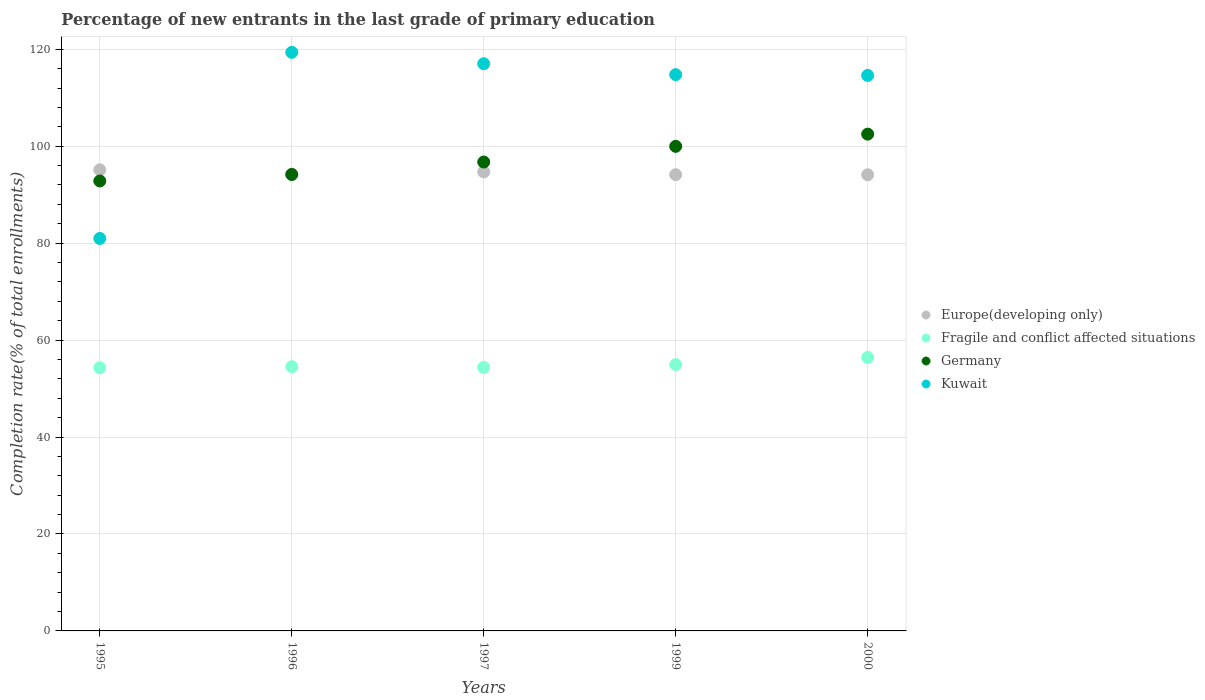How many different coloured dotlines are there?
Provide a short and direct response. 4. Is the number of dotlines equal to the number of legend labels?
Make the answer very short. Yes. What is the percentage of new entrants in Fragile and conflict affected situations in 1997?
Provide a short and direct response. 54.36. Across all years, what is the maximum percentage of new entrants in Fragile and conflict affected situations?
Your answer should be compact. 56.43. Across all years, what is the minimum percentage of new entrants in Kuwait?
Your answer should be very brief. 80.96. In which year was the percentage of new entrants in Kuwait minimum?
Offer a very short reply. 1995. What is the total percentage of new entrants in Fragile and conflict affected situations in the graph?
Keep it short and to the point. 274.54. What is the difference between the percentage of new entrants in Europe(developing only) in 1996 and that in 1997?
Offer a terse response. -0.46. What is the difference between the percentage of new entrants in Fragile and conflict affected situations in 1997 and the percentage of new entrants in Germany in 1999?
Offer a very short reply. -45.61. What is the average percentage of new entrants in Fragile and conflict affected situations per year?
Offer a terse response. 54.91. In the year 2000, what is the difference between the percentage of new entrants in Kuwait and percentage of new entrants in Germany?
Your response must be concise. 12.12. In how many years, is the percentage of new entrants in Europe(developing only) greater than 72 %?
Ensure brevity in your answer.  5. What is the ratio of the percentage of new entrants in Germany in 1995 to that in 1999?
Keep it short and to the point. 0.93. What is the difference between the highest and the second highest percentage of new entrants in Germany?
Your answer should be very brief. 2.52. What is the difference between the highest and the lowest percentage of new entrants in Germany?
Make the answer very short. 9.66. Is it the case that in every year, the sum of the percentage of new entrants in Germany and percentage of new entrants in Fragile and conflict affected situations  is greater than the sum of percentage of new entrants in Europe(developing only) and percentage of new entrants in Kuwait?
Give a very brief answer. No. Is it the case that in every year, the sum of the percentage of new entrants in Germany and percentage of new entrants in Kuwait  is greater than the percentage of new entrants in Fragile and conflict affected situations?
Make the answer very short. Yes. Is the percentage of new entrants in Kuwait strictly greater than the percentage of new entrants in Fragile and conflict affected situations over the years?
Offer a very short reply. Yes. Is the percentage of new entrants in Fragile and conflict affected situations strictly less than the percentage of new entrants in Kuwait over the years?
Your answer should be compact. Yes. What is the difference between two consecutive major ticks on the Y-axis?
Give a very brief answer. 20. Are the values on the major ticks of Y-axis written in scientific E-notation?
Your answer should be compact. No. Does the graph contain any zero values?
Provide a short and direct response. No. How many legend labels are there?
Make the answer very short. 4. What is the title of the graph?
Make the answer very short. Percentage of new entrants in the last grade of primary education. What is the label or title of the Y-axis?
Give a very brief answer. Completion rate(% of total enrollments). What is the Completion rate(% of total enrollments) of Europe(developing only) in 1995?
Give a very brief answer. 95.14. What is the Completion rate(% of total enrollments) in Fragile and conflict affected situations in 1995?
Your response must be concise. 54.29. What is the Completion rate(% of total enrollments) of Germany in 1995?
Your answer should be compact. 92.82. What is the Completion rate(% of total enrollments) of Kuwait in 1995?
Make the answer very short. 80.96. What is the Completion rate(% of total enrollments) in Europe(developing only) in 1996?
Offer a very short reply. 94.23. What is the Completion rate(% of total enrollments) in Fragile and conflict affected situations in 1996?
Give a very brief answer. 54.51. What is the Completion rate(% of total enrollments) of Germany in 1996?
Your answer should be very brief. 94.16. What is the Completion rate(% of total enrollments) of Kuwait in 1996?
Ensure brevity in your answer.  119.36. What is the Completion rate(% of total enrollments) in Europe(developing only) in 1997?
Make the answer very short. 94.69. What is the Completion rate(% of total enrollments) in Fragile and conflict affected situations in 1997?
Keep it short and to the point. 54.36. What is the Completion rate(% of total enrollments) of Germany in 1997?
Provide a short and direct response. 96.73. What is the Completion rate(% of total enrollments) in Kuwait in 1997?
Keep it short and to the point. 117.01. What is the Completion rate(% of total enrollments) in Europe(developing only) in 1999?
Keep it short and to the point. 94.12. What is the Completion rate(% of total enrollments) of Fragile and conflict affected situations in 1999?
Your response must be concise. 54.94. What is the Completion rate(% of total enrollments) in Germany in 1999?
Ensure brevity in your answer.  99.97. What is the Completion rate(% of total enrollments) of Kuwait in 1999?
Ensure brevity in your answer.  114.76. What is the Completion rate(% of total enrollments) of Europe(developing only) in 2000?
Your answer should be compact. 94.1. What is the Completion rate(% of total enrollments) in Fragile and conflict affected situations in 2000?
Make the answer very short. 56.43. What is the Completion rate(% of total enrollments) of Germany in 2000?
Keep it short and to the point. 102.49. What is the Completion rate(% of total enrollments) of Kuwait in 2000?
Provide a short and direct response. 114.61. Across all years, what is the maximum Completion rate(% of total enrollments) of Europe(developing only)?
Give a very brief answer. 95.14. Across all years, what is the maximum Completion rate(% of total enrollments) in Fragile and conflict affected situations?
Give a very brief answer. 56.43. Across all years, what is the maximum Completion rate(% of total enrollments) in Germany?
Provide a succinct answer. 102.49. Across all years, what is the maximum Completion rate(% of total enrollments) in Kuwait?
Your answer should be very brief. 119.36. Across all years, what is the minimum Completion rate(% of total enrollments) of Europe(developing only)?
Provide a succinct answer. 94.1. Across all years, what is the minimum Completion rate(% of total enrollments) of Fragile and conflict affected situations?
Provide a short and direct response. 54.29. Across all years, what is the minimum Completion rate(% of total enrollments) in Germany?
Offer a very short reply. 92.82. Across all years, what is the minimum Completion rate(% of total enrollments) in Kuwait?
Provide a succinct answer. 80.96. What is the total Completion rate(% of total enrollments) of Europe(developing only) in the graph?
Give a very brief answer. 472.27. What is the total Completion rate(% of total enrollments) of Fragile and conflict affected situations in the graph?
Your answer should be compact. 274.54. What is the total Completion rate(% of total enrollments) in Germany in the graph?
Provide a succinct answer. 486.17. What is the total Completion rate(% of total enrollments) of Kuwait in the graph?
Make the answer very short. 546.7. What is the difference between the Completion rate(% of total enrollments) of Europe(developing only) in 1995 and that in 1996?
Your answer should be compact. 0.91. What is the difference between the Completion rate(% of total enrollments) of Fragile and conflict affected situations in 1995 and that in 1996?
Offer a very short reply. -0.22. What is the difference between the Completion rate(% of total enrollments) in Germany in 1995 and that in 1996?
Your answer should be very brief. -1.34. What is the difference between the Completion rate(% of total enrollments) in Kuwait in 1995 and that in 1996?
Make the answer very short. -38.4. What is the difference between the Completion rate(% of total enrollments) in Europe(developing only) in 1995 and that in 1997?
Your answer should be very brief. 0.45. What is the difference between the Completion rate(% of total enrollments) in Fragile and conflict affected situations in 1995 and that in 1997?
Ensure brevity in your answer.  -0.07. What is the difference between the Completion rate(% of total enrollments) of Germany in 1995 and that in 1997?
Your answer should be compact. -3.91. What is the difference between the Completion rate(% of total enrollments) in Kuwait in 1995 and that in 1997?
Provide a succinct answer. -36.05. What is the difference between the Completion rate(% of total enrollments) in Europe(developing only) in 1995 and that in 1999?
Make the answer very short. 1.02. What is the difference between the Completion rate(% of total enrollments) of Fragile and conflict affected situations in 1995 and that in 1999?
Provide a succinct answer. -0.64. What is the difference between the Completion rate(% of total enrollments) in Germany in 1995 and that in 1999?
Ensure brevity in your answer.  -7.14. What is the difference between the Completion rate(% of total enrollments) in Kuwait in 1995 and that in 1999?
Provide a succinct answer. -33.8. What is the difference between the Completion rate(% of total enrollments) of Europe(developing only) in 1995 and that in 2000?
Provide a short and direct response. 1.04. What is the difference between the Completion rate(% of total enrollments) of Fragile and conflict affected situations in 1995 and that in 2000?
Provide a short and direct response. -2.14. What is the difference between the Completion rate(% of total enrollments) in Germany in 1995 and that in 2000?
Give a very brief answer. -9.66. What is the difference between the Completion rate(% of total enrollments) in Kuwait in 1995 and that in 2000?
Your answer should be compact. -33.64. What is the difference between the Completion rate(% of total enrollments) of Europe(developing only) in 1996 and that in 1997?
Ensure brevity in your answer.  -0.46. What is the difference between the Completion rate(% of total enrollments) in Fragile and conflict affected situations in 1996 and that in 1997?
Make the answer very short. 0.15. What is the difference between the Completion rate(% of total enrollments) in Germany in 1996 and that in 1997?
Your response must be concise. -2.57. What is the difference between the Completion rate(% of total enrollments) in Kuwait in 1996 and that in 1997?
Your answer should be very brief. 2.35. What is the difference between the Completion rate(% of total enrollments) in Europe(developing only) in 1996 and that in 1999?
Offer a very short reply. 0.11. What is the difference between the Completion rate(% of total enrollments) of Fragile and conflict affected situations in 1996 and that in 1999?
Your answer should be very brief. -0.42. What is the difference between the Completion rate(% of total enrollments) in Germany in 1996 and that in 1999?
Your answer should be very brief. -5.81. What is the difference between the Completion rate(% of total enrollments) of Kuwait in 1996 and that in 1999?
Keep it short and to the point. 4.6. What is the difference between the Completion rate(% of total enrollments) in Europe(developing only) in 1996 and that in 2000?
Make the answer very short. 0.13. What is the difference between the Completion rate(% of total enrollments) of Fragile and conflict affected situations in 1996 and that in 2000?
Your answer should be compact. -1.92. What is the difference between the Completion rate(% of total enrollments) of Germany in 1996 and that in 2000?
Provide a short and direct response. -8.33. What is the difference between the Completion rate(% of total enrollments) of Kuwait in 1996 and that in 2000?
Offer a terse response. 4.75. What is the difference between the Completion rate(% of total enrollments) of Europe(developing only) in 1997 and that in 1999?
Provide a short and direct response. 0.57. What is the difference between the Completion rate(% of total enrollments) in Fragile and conflict affected situations in 1997 and that in 1999?
Offer a very short reply. -0.58. What is the difference between the Completion rate(% of total enrollments) in Germany in 1997 and that in 1999?
Ensure brevity in your answer.  -3.23. What is the difference between the Completion rate(% of total enrollments) of Kuwait in 1997 and that in 1999?
Make the answer very short. 2.25. What is the difference between the Completion rate(% of total enrollments) in Europe(developing only) in 1997 and that in 2000?
Your answer should be compact. 0.59. What is the difference between the Completion rate(% of total enrollments) in Fragile and conflict affected situations in 1997 and that in 2000?
Provide a short and direct response. -2.07. What is the difference between the Completion rate(% of total enrollments) in Germany in 1997 and that in 2000?
Your answer should be compact. -5.76. What is the difference between the Completion rate(% of total enrollments) in Kuwait in 1997 and that in 2000?
Ensure brevity in your answer.  2.4. What is the difference between the Completion rate(% of total enrollments) of Europe(developing only) in 1999 and that in 2000?
Keep it short and to the point. 0.02. What is the difference between the Completion rate(% of total enrollments) in Fragile and conflict affected situations in 1999 and that in 2000?
Provide a succinct answer. -1.5. What is the difference between the Completion rate(% of total enrollments) in Germany in 1999 and that in 2000?
Your answer should be compact. -2.52. What is the difference between the Completion rate(% of total enrollments) in Kuwait in 1999 and that in 2000?
Give a very brief answer. 0.15. What is the difference between the Completion rate(% of total enrollments) in Europe(developing only) in 1995 and the Completion rate(% of total enrollments) in Fragile and conflict affected situations in 1996?
Offer a terse response. 40.62. What is the difference between the Completion rate(% of total enrollments) of Europe(developing only) in 1995 and the Completion rate(% of total enrollments) of Germany in 1996?
Keep it short and to the point. 0.98. What is the difference between the Completion rate(% of total enrollments) of Europe(developing only) in 1995 and the Completion rate(% of total enrollments) of Kuwait in 1996?
Keep it short and to the point. -24.22. What is the difference between the Completion rate(% of total enrollments) in Fragile and conflict affected situations in 1995 and the Completion rate(% of total enrollments) in Germany in 1996?
Ensure brevity in your answer.  -39.87. What is the difference between the Completion rate(% of total enrollments) of Fragile and conflict affected situations in 1995 and the Completion rate(% of total enrollments) of Kuwait in 1996?
Make the answer very short. -65.07. What is the difference between the Completion rate(% of total enrollments) of Germany in 1995 and the Completion rate(% of total enrollments) of Kuwait in 1996?
Provide a short and direct response. -26.54. What is the difference between the Completion rate(% of total enrollments) of Europe(developing only) in 1995 and the Completion rate(% of total enrollments) of Fragile and conflict affected situations in 1997?
Give a very brief answer. 40.78. What is the difference between the Completion rate(% of total enrollments) in Europe(developing only) in 1995 and the Completion rate(% of total enrollments) in Germany in 1997?
Give a very brief answer. -1.6. What is the difference between the Completion rate(% of total enrollments) in Europe(developing only) in 1995 and the Completion rate(% of total enrollments) in Kuwait in 1997?
Your answer should be very brief. -21.87. What is the difference between the Completion rate(% of total enrollments) in Fragile and conflict affected situations in 1995 and the Completion rate(% of total enrollments) in Germany in 1997?
Ensure brevity in your answer.  -42.44. What is the difference between the Completion rate(% of total enrollments) of Fragile and conflict affected situations in 1995 and the Completion rate(% of total enrollments) of Kuwait in 1997?
Make the answer very short. -62.72. What is the difference between the Completion rate(% of total enrollments) in Germany in 1995 and the Completion rate(% of total enrollments) in Kuwait in 1997?
Offer a very short reply. -24.19. What is the difference between the Completion rate(% of total enrollments) of Europe(developing only) in 1995 and the Completion rate(% of total enrollments) of Fragile and conflict affected situations in 1999?
Offer a very short reply. 40.2. What is the difference between the Completion rate(% of total enrollments) in Europe(developing only) in 1995 and the Completion rate(% of total enrollments) in Germany in 1999?
Your answer should be very brief. -4.83. What is the difference between the Completion rate(% of total enrollments) of Europe(developing only) in 1995 and the Completion rate(% of total enrollments) of Kuwait in 1999?
Your answer should be compact. -19.62. What is the difference between the Completion rate(% of total enrollments) in Fragile and conflict affected situations in 1995 and the Completion rate(% of total enrollments) in Germany in 1999?
Offer a terse response. -45.67. What is the difference between the Completion rate(% of total enrollments) of Fragile and conflict affected situations in 1995 and the Completion rate(% of total enrollments) of Kuwait in 1999?
Ensure brevity in your answer.  -60.47. What is the difference between the Completion rate(% of total enrollments) in Germany in 1995 and the Completion rate(% of total enrollments) in Kuwait in 1999?
Your answer should be very brief. -21.94. What is the difference between the Completion rate(% of total enrollments) in Europe(developing only) in 1995 and the Completion rate(% of total enrollments) in Fragile and conflict affected situations in 2000?
Your answer should be very brief. 38.7. What is the difference between the Completion rate(% of total enrollments) of Europe(developing only) in 1995 and the Completion rate(% of total enrollments) of Germany in 2000?
Keep it short and to the point. -7.35. What is the difference between the Completion rate(% of total enrollments) in Europe(developing only) in 1995 and the Completion rate(% of total enrollments) in Kuwait in 2000?
Make the answer very short. -19.47. What is the difference between the Completion rate(% of total enrollments) in Fragile and conflict affected situations in 1995 and the Completion rate(% of total enrollments) in Germany in 2000?
Your response must be concise. -48.2. What is the difference between the Completion rate(% of total enrollments) in Fragile and conflict affected situations in 1995 and the Completion rate(% of total enrollments) in Kuwait in 2000?
Offer a very short reply. -60.31. What is the difference between the Completion rate(% of total enrollments) in Germany in 1995 and the Completion rate(% of total enrollments) in Kuwait in 2000?
Your response must be concise. -21.78. What is the difference between the Completion rate(% of total enrollments) of Europe(developing only) in 1996 and the Completion rate(% of total enrollments) of Fragile and conflict affected situations in 1997?
Provide a succinct answer. 39.87. What is the difference between the Completion rate(% of total enrollments) of Europe(developing only) in 1996 and the Completion rate(% of total enrollments) of Germany in 1997?
Give a very brief answer. -2.5. What is the difference between the Completion rate(% of total enrollments) in Europe(developing only) in 1996 and the Completion rate(% of total enrollments) in Kuwait in 1997?
Provide a short and direct response. -22.78. What is the difference between the Completion rate(% of total enrollments) of Fragile and conflict affected situations in 1996 and the Completion rate(% of total enrollments) of Germany in 1997?
Your response must be concise. -42.22. What is the difference between the Completion rate(% of total enrollments) in Fragile and conflict affected situations in 1996 and the Completion rate(% of total enrollments) in Kuwait in 1997?
Make the answer very short. -62.5. What is the difference between the Completion rate(% of total enrollments) in Germany in 1996 and the Completion rate(% of total enrollments) in Kuwait in 1997?
Give a very brief answer. -22.85. What is the difference between the Completion rate(% of total enrollments) in Europe(developing only) in 1996 and the Completion rate(% of total enrollments) in Fragile and conflict affected situations in 1999?
Offer a very short reply. 39.29. What is the difference between the Completion rate(% of total enrollments) in Europe(developing only) in 1996 and the Completion rate(% of total enrollments) in Germany in 1999?
Your answer should be compact. -5.74. What is the difference between the Completion rate(% of total enrollments) of Europe(developing only) in 1996 and the Completion rate(% of total enrollments) of Kuwait in 1999?
Your response must be concise. -20.53. What is the difference between the Completion rate(% of total enrollments) of Fragile and conflict affected situations in 1996 and the Completion rate(% of total enrollments) of Germany in 1999?
Your response must be concise. -45.45. What is the difference between the Completion rate(% of total enrollments) in Fragile and conflict affected situations in 1996 and the Completion rate(% of total enrollments) in Kuwait in 1999?
Make the answer very short. -60.25. What is the difference between the Completion rate(% of total enrollments) in Germany in 1996 and the Completion rate(% of total enrollments) in Kuwait in 1999?
Your answer should be compact. -20.6. What is the difference between the Completion rate(% of total enrollments) of Europe(developing only) in 1996 and the Completion rate(% of total enrollments) of Fragile and conflict affected situations in 2000?
Ensure brevity in your answer.  37.79. What is the difference between the Completion rate(% of total enrollments) of Europe(developing only) in 1996 and the Completion rate(% of total enrollments) of Germany in 2000?
Offer a very short reply. -8.26. What is the difference between the Completion rate(% of total enrollments) of Europe(developing only) in 1996 and the Completion rate(% of total enrollments) of Kuwait in 2000?
Your answer should be very brief. -20.38. What is the difference between the Completion rate(% of total enrollments) in Fragile and conflict affected situations in 1996 and the Completion rate(% of total enrollments) in Germany in 2000?
Offer a terse response. -47.97. What is the difference between the Completion rate(% of total enrollments) in Fragile and conflict affected situations in 1996 and the Completion rate(% of total enrollments) in Kuwait in 2000?
Your answer should be very brief. -60.09. What is the difference between the Completion rate(% of total enrollments) in Germany in 1996 and the Completion rate(% of total enrollments) in Kuwait in 2000?
Make the answer very short. -20.45. What is the difference between the Completion rate(% of total enrollments) of Europe(developing only) in 1997 and the Completion rate(% of total enrollments) of Fragile and conflict affected situations in 1999?
Your answer should be very brief. 39.75. What is the difference between the Completion rate(% of total enrollments) in Europe(developing only) in 1997 and the Completion rate(% of total enrollments) in Germany in 1999?
Your answer should be very brief. -5.28. What is the difference between the Completion rate(% of total enrollments) in Europe(developing only) in 1997 and the Completion rate(% of total enrollments) in Kuwait in 1999?
Make the answer very short. -20.07. What is the difference between the Completion rate(% of total enrollments) in Fragile and conflict affected situations in 1997 and the Completion rate(% of total enrollments) in Germany in 1999?
Ensure brevity in your answer.  -45.61. What is the difference between the Completion rate(% of total enrollments) in Fragile and conflict affected situations in 1997 and the Completion rate(% of total enrollments) in Kuwait in 1999?
Provide a succinct answer. -60.4. What is the difference between the Completion rate(% of total enrollments) in Germany in 1997 and the Completion rate(% of total enrollments) in Kuwait in 1999?
Keep it short and to the point. -18.03. What is the difference between the Completion rate(% of total enrollments) in Europe(developing only) in 1997 and the Completion rate(% of total enrollments) in Fragile and conflict affected situations in 2000?
Provide a succinct answer. 38.25. What is the difference between the Completion rate(% of total enrollments) in Europe(developing only) in 1997 and the Completion rate(% of total enrollments) in Germany in 2000?
Provide a short and direct response. -7.8. What is the difference between the Completion rate(% of total enrollments) in Europe(developing only) in 1997 and the Completion rate(% of total enrollments) in Kuwait in 2000?
Give a very brief answer. -19.92. What is the difference between the Completion rate(% of total enrollments) of Fragile and conflict affected situations in 1997 and the Completion rate(% of total enrollments) of Germany in 2000?
Ensure brevity in your answer.  -48.13. What is the difference between the Completion rate(% of total enrollments) of Fragile and conflict affected situations in 1997 and the Completion rate(% of total enrollments) of Kuwait in 2000?
Offer a very short reply. -60.25. What is the difference between the Completion rate(% of total enrollments) in Germany in 1997 and the Completion rate(% of total enrollments) in Kuwait in 2000?
Provide a succinct answer. -17.87. What is the difference between the Completion rate(% of total enrollments) of Europe(developing only) in 1999 and the Completion rate(% of total enrollments) of Fragile and conflict affected situations in 2000?
Make the answer very short. 37.68. What is the difference between the Completion rate(% of total enrollments) in Europe(developing only) in 1999 and the Completion rate(% of total enrollments) in Germany in 2000?
Provide a short and direct response. -8.37. What is the difference between the Completion rate(% of total enrollments) in Europe(developing only) in 1999 and the Completion rate(% of total enrollments) in Kuwait in 2000?
Keep it short and to the point. -20.49. What is the difference between the Completion rate(% of total enrollments) of Fragile and conflict affected situations in 1999 and the Completion rate(% of total enrollments) of Germany in 2000?
Provide a succinct answer. -47.55. What is the difference between the Completion rate(% of total enrollments) in Fragile and conflict affected situations in 1999 and the Completion rate(% of total enrollments) in Kuwait in 2000?
Make the answer very short. -59.67. What is the difference between the Completion rate(% of total enrollments) in Germany in 1999 and the Completion rate(% of total enrollments) in Kuwait in 2000?
Your response must be concise. -14.64. What is the average Completion rate(% of total enrollments) of Europe(developing only) per year?
Provide a succinct answer. 94.45. What is the average Completion rate(% of total enrollments) of Fragile and conflict affected situations per year?
Your response must be concise. 54.91. What is the average Completion rate(% of total enrollments) of Germany per year?
Your response must be concise. 97.23. What is the average Completion rate(% of total enrollments) of Kuwait per year?
Provide a succinct answer. 109.34. In the year 1995, what is the difference between the Completion rate(% of total enrollments) of Europe(developing only) and Completion rate(% of total enrollments) of Fragile and conflict affected situations?
Your response must be concise. 40.84. In the year 1995, what is the difference between the Completion rate(% of total enrollments) in Europe(developing only) and Completion rate(% of total enrollments) in Germany?
Give a very brief answer. 2.31. In the year 1995, what is the difference between the Completion rate(% of total enrollments) of Europe(developing only) and Completion rate(% of total enrollments) of Kuwait?
Provide a short and direct response. 14.17. In the year 1995, what is the difference between the Completion rate(% of total enrollments) of Fragile and conflict affected situations and Completion rate(% of total enrollments) of Germany?
Your answer should be compact. -38.53. In the year 1995, what is the difference between the Completion rate(% of total enrollments) in Fragile and conflict affected situations and Completion rate(% of total enrollments) in Kuwait?
Keep it short and to the point. -26.67. In the year 1995, what is the difference between the Completion rate(% of total enrollments) in Germany and Completion rate(% of total enrollments) in Kuwait?
Give a very brief answer. 11.86. In the year 1996, what is the difference between the Completion rate(% of total enrollments) in Europe(developing only) and Completion rate(% of total enrollments) in Fragile and conflict affected situations?
Provide a succinct answer. 39.71. In the year 1996, what is the difference between the Completion rate(% of total enrollments) of Europe(developing only) and Completion rate(% of total enrollments) of Germany?
Provide a succinct answer. 0.07. In the year 1996, what is the difference between the Completion rate(% of total enrollments) in Europe(developing only) and Completion rate(% of total enrollments) in Kuwait?
Provide a short and direct response. -25.13. In the year 1996, what is the difference between the Completion rate(% of total enrollments) in Fragile and conflict affected situations and Completion rate(% of total enrollments) in Germany?
Your answer should be very brief. -39.65. In the year 1996, what is the difference between the Completion rate(% of total enrollments) of Fragile and conflict affected situations and Completion rate(% of total enrollments) of Kuwait?
Your response must be concise. -64.85. In the year 1996, what is the difference between the Completion rate(% of total enrollments) in Germany and Completion rate(% of total enrollments) in Kuwait?
Provide a short and direct response. -25.2. In the year 1997, what is the difference between the Completion rate(% of total enrollments) of Europe(developing only) and Completion rate(% of total enrollments) of Fragile and conflict affected situations?
Keep it short and to the point. 40.33. In the year 1997, what is the difference between the Completion rate(% of total enrollments) of Europe(developing only) and Completion rate(% of total enrollments) of Germany?
Give a very brief answer. -2.04. In the year 1997, what is the difference between the Completion rate(% of total enrollments) of Europe(developing only) and Completion rate(% of total enrollments) of Kuwait?
Keep it short and to the point. -22.32. In the year 1997, what is the difference between the Completion rate(% of total enrollments) in Fragile and conflict affected situations and Completion rate(% of total enrollments) in Germany?
Make the answer very short. -42.37. In the year 1997, what is the difference between the Completion rate(% of total enrollments) in Fragile and conflict affected situations and Completion rate(% of total enrollments) in Kuwait?
Keep it short and to the point. -62.65. In the year 1997, what is the difference between the Completion rate(% of total enrollments) of Germany and Completion rate(% of total enrollments) of Kuwait?
Keep it short and to the point. -20.28. In the year 1999, what is the difference between the Completion rate(% of total enrollments) of Europe(developing only) and Completion rate(% of total enrollments) of Fragile and conflict affected situations?
Provide a short and direct response. 39.18. In the year 1999, what is the difference between the Completion rate(% of total enrollments) in Europe(developing only) and Completion rate(% of total enrollments) in Germany?
Your answer should be compact. -5.85. In the year 1999, what is the difference between the Completion rate(% of total enrollments) of Europe(developing only) and Completion rate(% of total enrollments) of Kuwait?
Offer a terse response. -20.64. In the year 1999, what is the difference between the Completion rate(% of total enrollments) of Fragile and conflict affected situations and Completion rate(% of total enrollments) of Germany?
Offer a very short reply. -45.03. In the year 1999, what is the difference between the Completion rate(% of total enrollments) of Fragile and conflict affected situations and Completion rate(% of total enrollments) of Kuwait?
Your response must be concise. -59.82. In the year 1999, what is the difference between the Completion rate(% of total enrollments) of Germany and Completion rate(% of total enrollments) of Kuwait?
Provide a succinct answer. -14.79. In the year 2000, what is the difference between the Completion rate(% of total enrollments) in Europe(developing only) and Completion rate(% of total enrollments) in Fragile and conflict affected situations?
Give a very brief answer. 37.67. In the year 2000, what is the difference between the Completion rate(% of total enrollments) in Europe(developing only) and Completion rate(% of total enrollments) in Germany?
Make the answer very short. -8.39. In the year 2000, what is the difference between the Completion rate(% of total enrollments) in Europe(developing only) and Completion rate(% of total enrollments) in Kuwait?
Ensure brevity in your answer.  -20.51. In the year 2000, what is the difference between the Completion rate(% of total enrollments) of Fragile and conflict affected situations and Completion rate(% of total enrollments) of Germany?
Make the answer very short. -46.05. In the year 2000, what is the difference between the Completion rate(% of total enrollments) in Fragile and conflict affected situations and Completion rate(% of total enrollments) in Kuwait?
Provide a succinct answer. -58.17. In the year 2000, what is the difference between the Completion rate(% of total enrollments) of Germany and Completion rate(% of total enrollments) of Kuwait?
Give a very brief answer. -12.12. What is the ratio of the Completion rate(% of total enrollments) in Europe(developing only) in 1995 to that in 1996?
Your response must be concise. 1.01. What is the ratio of the Completion rate(% of total enrollments) of Fragile and conflict affected situations in 1995 to that in 1996?
Ensure brevity in your answer.  1. What is the ratio of the Completion rate(% of total enrollments) in Germany in 1995 to that in 1996?
Your answer should be very brief. 0.99. What is the ratio of the Completion rate(% of total enrollments) in Kuwait in 1995 to that in 1996?
Your answer should be compact. 0.68. What is the ratio of the Completion rate(% of total enrollments) in Fragile and conflict affected situations in 1995 to that in 1997?
Your answer should be compact. 1. What is the ratio of the Completion rate(% of total enrollments) of Germany in 1995 to that in 1997?
Keep it short and to the point. 0.96. What is the ratio of the Completion rate(% of total enrollments) in Kuwait in 1995 to that in 1997?
Give a very brief answer. 0.69. What is the ratio of the Completion rate(% of total enrollments) of Europe(developing only) in 1995 to that in 1999?
Offer a very short reply. 1.01. What is the ratio of the Completion rate(% of total enrollments) of Fragile and conflict affected situations in 1995 to that in 1999?
Provide a succinct answer. 0.99. What is the ratio of the Completion rate(% of total enrollments) in Germany in 1995 to that in 1999?
Give a very brief answer. 0.93. What is the ratio of the Completion rate(% of total enrollments) of Kuwait in 1995 to that in 1999?
Provide a succinct answer. 0.71. What is the ratio of the Completion rate(% of total enrollments) of Europe(developing only) in 1995 to that in 2000?
Give a very brief answer. 1.01. What is the ratio of the Completion rate(% of total enrollments) of Germany in 1995 to that in 2000?
Offer a terse response. 0.91. What is the ratio of the Completion rate(% of total enrollments) of Kuwait in 1995 to that in 2000?
Your response must be concise. 0.71. What is the ratio of the Completion rate(% of total enrollments) in Germany in 1996 to that in 1997?
Give a very brief answer. 0.97. What is the ratio of the Completion rate(% of total enrollments) in Kuwait in 1996 to that in 1997?
Provide a short and direct response. 1.02. What is the ratio of the Completion rate(% of total enrollments) of Germany in 1996 to that in 1999?
Your answer should be compact. 0.94. What is the ratio of the Completion rate(% of total enrollments) in Kuwait in 1996 to that in 1999?
Your answer should be compact. 1.04. What is the ratio of the Completion rate(% of total enrollments) of Fragile and conflict affected situations in 1996 to that in 2000?
Offer a very short reply. 0.97. What is the ratio of the Completion rate(% of total enrollments) of Germany in 1996 to that in 2000?
Ensure brevity in your answer.  0.92. What is the ratio of the Completion rate(% of total enrollments) in Kuwait in 1996 to that in 2000?
Provide a succinct answer. 1.04. What is the ratio of the Completion rate(% of total enrollments) in Germany in 1997 to that in 1999?
Offer a very short reply. 0.97. What is the ratio of the Completion rate(% of total enrollments) in Kuwait in 1997 to that in 1999?
Give a very brief answer. 1.02. What is the ratio of the Completion rate(% of total enrollments) of Fragile and conflict affected situations in 1997 to that in 2000?
Keep it short and to the point. 0.96. What is the ratio of the Completion rate(% of total enrollments) of Germany in 1997 to that in 2000?
Offer a very short reply. 0.94. What is the ratio of the Completion rate(% of total enrollments) in Fragile and conflict affected situations in 1999 to that in 2000?
Make the answer very short. 0.97. What is the ratio of the Completion rate(% of total enrollments) of Germany in 1999 to that in 2000?
Provide a short and direct response. 0.98. What is the ratio of the Completion rate(% of total enrollments) of Kuwait in 1999 to that in 2000?
Provide a short and direct response. 1. What is the difference between the highest and the second highest Completion rate(% of total enrollments) in Europe(developing only)?
Provide a short and direct response. 0.45. What is the difference between the highest and the second highest Completion rate(% of total enrollments) in Fragile and conflict affected situations?
Your answer should be compact. 1.5. What is the difference between the highest and the second highest Completion rate(% of total enrollments) in Germany?
Offer a very short reply. 2.52. What is the difference between the highest and the second highest Completion rate(% of total enrollments) of Kuwait?
Your answer should be very brief. 2.35. What is the difference between the highest and the lowest Completion rate(% of total enrollments) in Europe(developing only)?
Offer a very short reply. 1.04. What is the difference between the highest and the lowest Completion rate(% of total enrollments) of Fragile and conflict affected situations?
Your response must be concise. 2.14. What is the difference between the highest and the lowest Completion rate(% of total enrollments) of Germany?
Provide a succinct answer. 9.66. What is the difference between the highest and the lowest Completion rate(% of total enrollments) of Kuwait?
Ensure brevity in your answer.  38.4. 